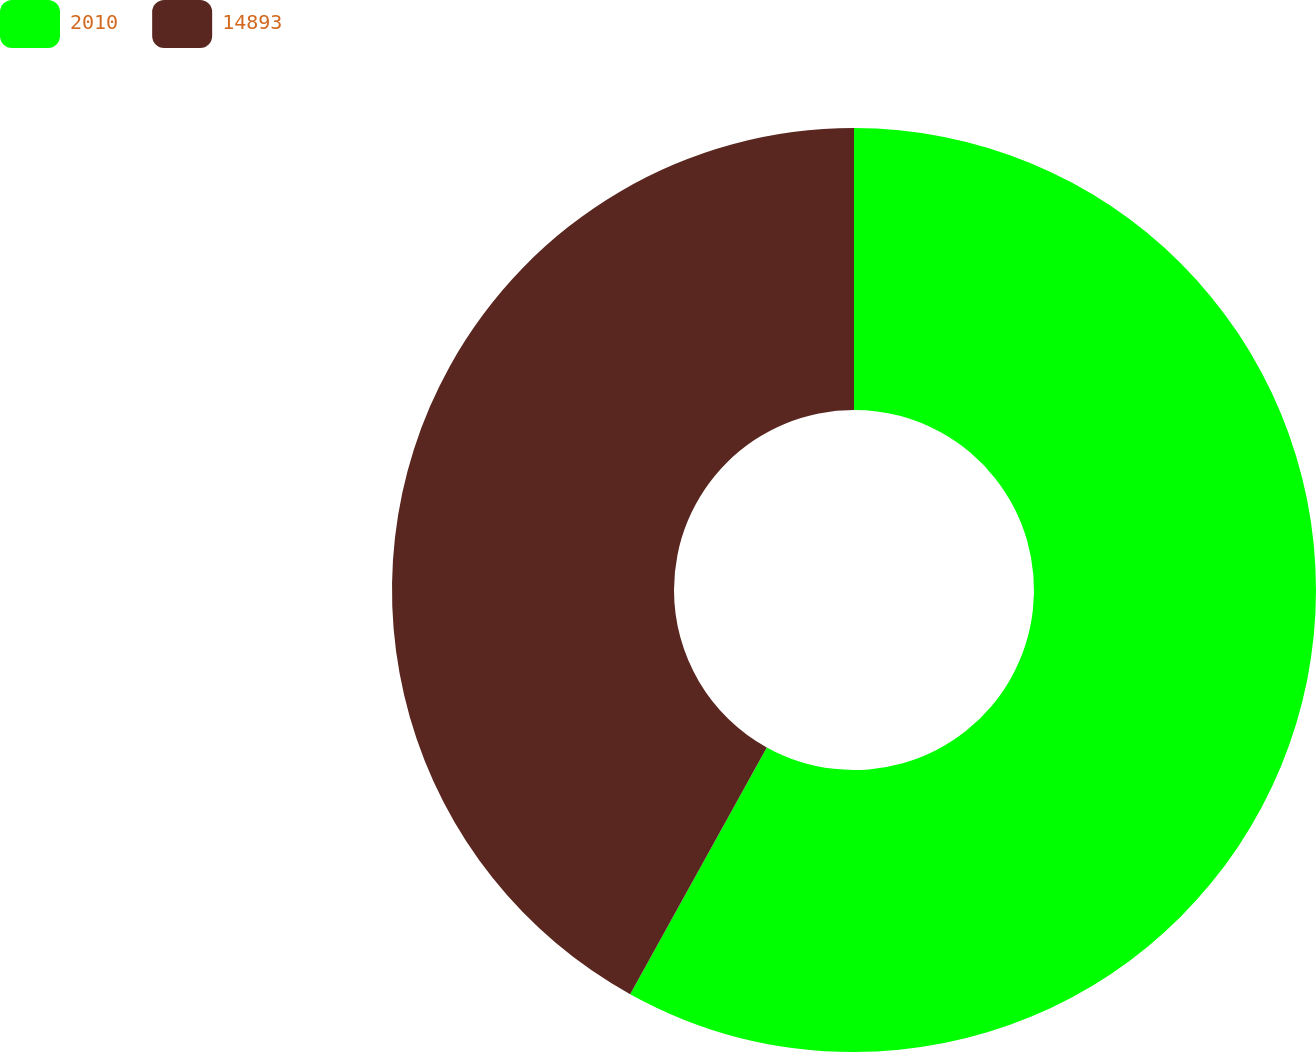Convert chart to OTSL. <chart><loc_0><loc_0><loc_500><loc_500><pie_chart><fcel>2010<fcel>14893<nl><fcel>58.05%<fcel>41.95%<nl></chart> 